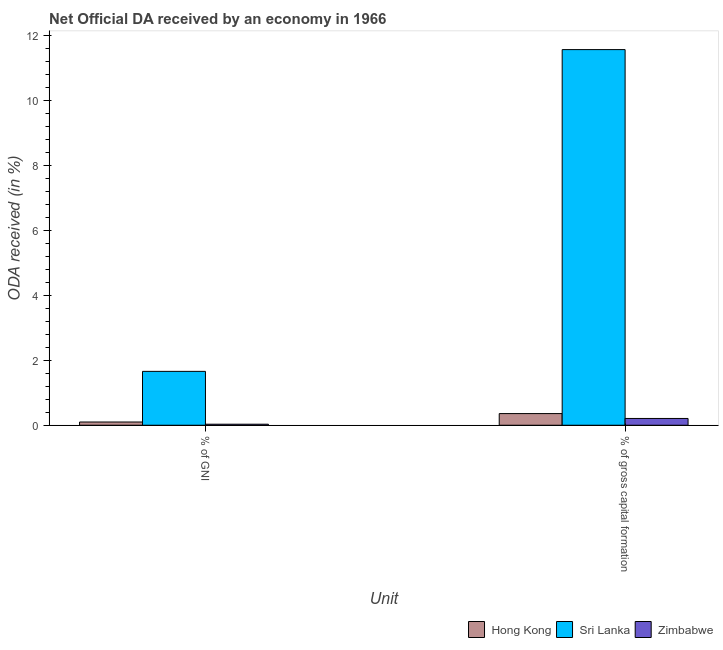How many groups of bars are there?
Give a very brief answer. 2. Are the number of bars on each tick of the X-axis equal?
Give a very brief answer. Yes. How many bars are there on the 2nd tick from the right?
Provide a short and direct response. 3. What is the label of the 1st group of bars from the left?
Offer a very short reply. % of GNI. What is the oda received as percentage of gross capital formation in Zimbabwe?
Make the answer very short. 0.21. Across all countries, what is the maximum oda received as percentage of gross capital formation?
Your answer should be very brief. 11.56. Across all countries, what is the minimum oda received as percentage of gross capital formation?
Keep it short and to the point. 0.21. In which country was the oda received as percentage of gni maximum?
Provide a succinct answer. Sri Lanka. In which country was the oda received as percentage of gni minimum?
Your response must be concise. Zimbabwe. What is the total oda received as percentage of gross capital formation in the graph?
Provide a succinct answer. 12.13. What is the difference between the oda received as percentage of gni in Zimbabwe and that in Hong Kong?
Your answer should be very brief. -0.07. What is the difference between the oda received as percentage of gross capital formation in Hong Kong and the oda received as percentage of gni in Sri Lanka?
Provide a short and direct response. -1.3. What is the average oda received as percentage of gni per country?
Offer a very short reply. 0.6. What is the difference between the oda received as percentage of gni and oda received as percentage of gross capital formation in Zimbabwe?
Provide a succinct answer. -0.18. In how many countries, is the oda received as percentage of gni greater than 3.2 %?
Offer a very short reply. 0. What is the ratio of the oda received as percentage of gni in Hong Kong to that in Sri Lanka?
Your answer should be very brief. 0.06. What does the 1st bar from the left in % of gross capital formation represents?
Keep it short and to the point. Hong Kong. What does the 3rd bar from the right in % of gross capital formation represents?
Your response must be concise. Hong Kong. How many bars are there?
Provide a succinct answer. 6. Are the values on the major ticks of Y-axis written in scientific E-notation?
Ensure brevity in your answer.  No. Does the graph contain any zero values?
Offer a terse response. No. Where does the legend appear in the graph?
Provide a succinct answer. Bottom right. How are the legend labels stacked?
Your answer should be compact. Horizontal. What is the title of the graph?
Provide a short and direct response. Net Official DA received by an economy in 1966. Does "Greenland" appear as one of the legend labels in the graph?
Your answer should be very brief. No. What is the label or title of the X-axis?
Make the answer very short. Unit. What is the label or title of the Y-axis?
Offer a very short reply. ODA received (in %). What is the ODA received (in %) of Hong Kong in % of GNI?
Offer a terse response. 0.1. What is the ODA received (in %) of Sri Lanka in % of GNI?
Keep it short and to the point. 1.66. What is the ODA received (in %) of Zimbabwe in % of GNI?
Ensure brevity in your answer.  0.03. What is the ODA received (in %) in Hong Kong in % of gross capital formation?
Keep it short and to the point. 0.36. What is the ODA received (in %) in Sri Lanka in % of gross capital formation?
Ensure brevity in your answer.  11.56. What is the ODA received (in %) in Zimbabwe in % of gross capital formation?
Offer a terse response. 0.21. Across all Unit, what is the maximum ODA received (in %) in Hong Kong?
Ensure brevity in your answer.  0.36. Across all Unit, what is the maximum ODA received (in %) in Sri Lanka?
Offer a very short reply. 11.56. Across all Unit, what is the maximum ODA received (in %) of Zimbabwe?
Your answer should be compact. 0.21. Across all Unit, what is the minimum ODA received (in %) in Hong Kong?
Offer a terse response. 0.1. Across all Unit, what is the minimum ODA received (in %) in Sri Lanka?
Your answer should be very brief. 1.66. Across all Unit, what is the minimum ODA received (in %) in Zimbabwe?
Offer a very short reply. 0.03. What is the total ODA received (in %) in Hong Kong in the graph?
Provide a short and direct response. 0.46. What is the total ODA received (in %) of Sri Lanka in the graph?
Your answer should be very brief. 13.22. What is the total ODA received (in %) of Zimbabwe in the graph?
Your response must be concise. 0.24. What is the difference between the ODA received (in %) of Hong Kong in % of GNI and that in % of gross capital formation?
Offer a terse response. -0.26. What is the difference between the ODA received (in %) in Sri Lanka in % of GNI and that in % of gross capital formation?
Make the answer very short. -9.91. What is the difference between the ODA received (in %) in Zimbabwe in % of GNI and that in % of gross capital formation?
Provide a short and direct response. -0.18. What is the difference between the ODA received (in %) in Hong Kong in % of GNI and the ODA received (in %) in Sri Lanka in % of gross capital formation?
Make the answer very short. -11.46. What is the difference between the ODA received (in %) of Hong Kong in % of GNI and the ODA received (in %) of Zimbabwe in % of gross capital formation?
Your response must be concise. -0.11. What is the difference between the ODA received (in %) in Sri Lanka in % of GNI and the ODA received (in %) in Zimbabwe in % of gross capital formation?
Your answer should be very brief. 1.45. What is the average ODA received (in %) in Hong Kong per Unit?
Provide a succinct answer. 0.23. What is the average ODA received (in %) in Sri Lanka per Unit?
Make the answer very short. 6.61. What is the average ODA received (in %) in Zimbabwe per Unit?
Make the answer very short. 0.12. What is the difference between the ODA received (in %) in Hong Kong and ODA received (in %) in Sri Lanka in % of GNI?
Offer a very short reply. -1.56. What is the difference between the ODA received (in %) of Hong Kong and ODA received (in %) of Zimbabwe in % of GNI?
Give a very brief answer. 0.07. What is the difference between the ODA received (in %) of Sri Lanka and ODA received (in %) of Zimbabwe in % of GNI?
Make the answer very short. 1.63. What is the difference between the ODA received (in %) in Hong Kong and ODA received (in %) in Sri Lanka in % of gross capital formation?
Provide a succinct answer. -11.2. What is the difference between the ODA received (in %) of Hong Kong and ODA received (in %) of Zimbabwe in % of gross capital formation?
Offer a terse response. 0.15. What is the difference between the ODA received (in %) of Sri Lanka and ODA received (in %) of Zimbabwe in % of gross capital formation?
Offer a very short reply. 11.35. What is the ratio of the ODA received (in %) in Hong Kong in % of GNI to that in % of gross capital formation?
Keep it short and to the point. 0.28. What is the ratio of the ODA received (in %) of Sri Lanka in % of GNI to that in % of gross capital formation?
Ensure brevity in your answer.  0.14. What is the ratio of the ODA received (in %) in Zimbabwe in % of GNI to that in % of gross capital formation?
Ensure brevity in your answer.  0.15. What is the difference between the highest and the second highest ODA received (in %) of Hong Kong?
Keep it short and to the point. 0.26. What is the difference between the highest and the second highest ODA received (in %) of Sri Lanka?
Make the answer very short. 9.91. What is the difference between the highest and the second highest ODA received (in %) of Zimbabwe?
Offer a very short reply. 0.18. What is the difference between the highest and the lowest ODA received (in %) of Hong Kong?
Offer a terse response. 0.26. What is the difference between the highest and the lowest ODA received (in %) of Sri Lanka?
Provide a short and direct response. 9.91. What is the difference between the highest and the lowest ODA received (in %) of Zimbabwe?
Ensure brevity in your answer.  0.18. 